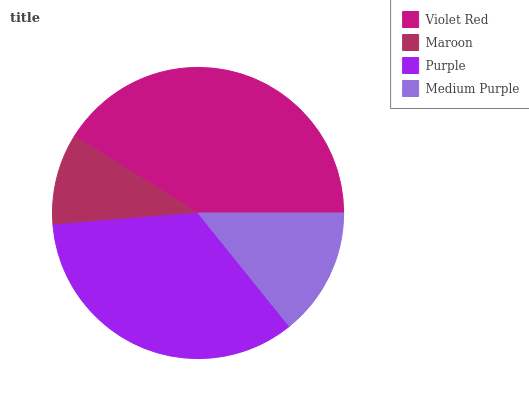Is Maroon the minimum?
Answer yes or no. Yes. Is Violet Red the maximum?
Answer yes or no. Yes. Is Purple the minimum?
Answer yes or no. No. Is Purple the maximum?
Answer yes or no. No. Is Purple greater than Maroon?
Answer yes or no. Yes. Is Maroon less than Purple?
Answer yes or no. Yes. Is Maroon greater than Purple?
Answer yes or no. No. Is Purple less than Maroon?
Answer yes or no. No. Is Purple the high median?
Answer yes or no. Yes. Is Medium Purple the low median?
Answer yes or no. Yes. Is Medium Purple the high median?
Answer yes or no. No. Is Violet Red the low median?
Answer yes or no. No. 